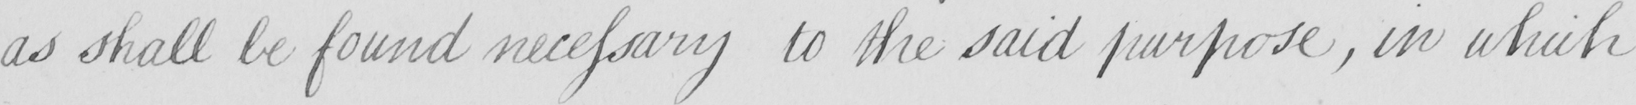Please provide the text content of this handwritten line. as shall be found necessary to the said purpose  , in which 